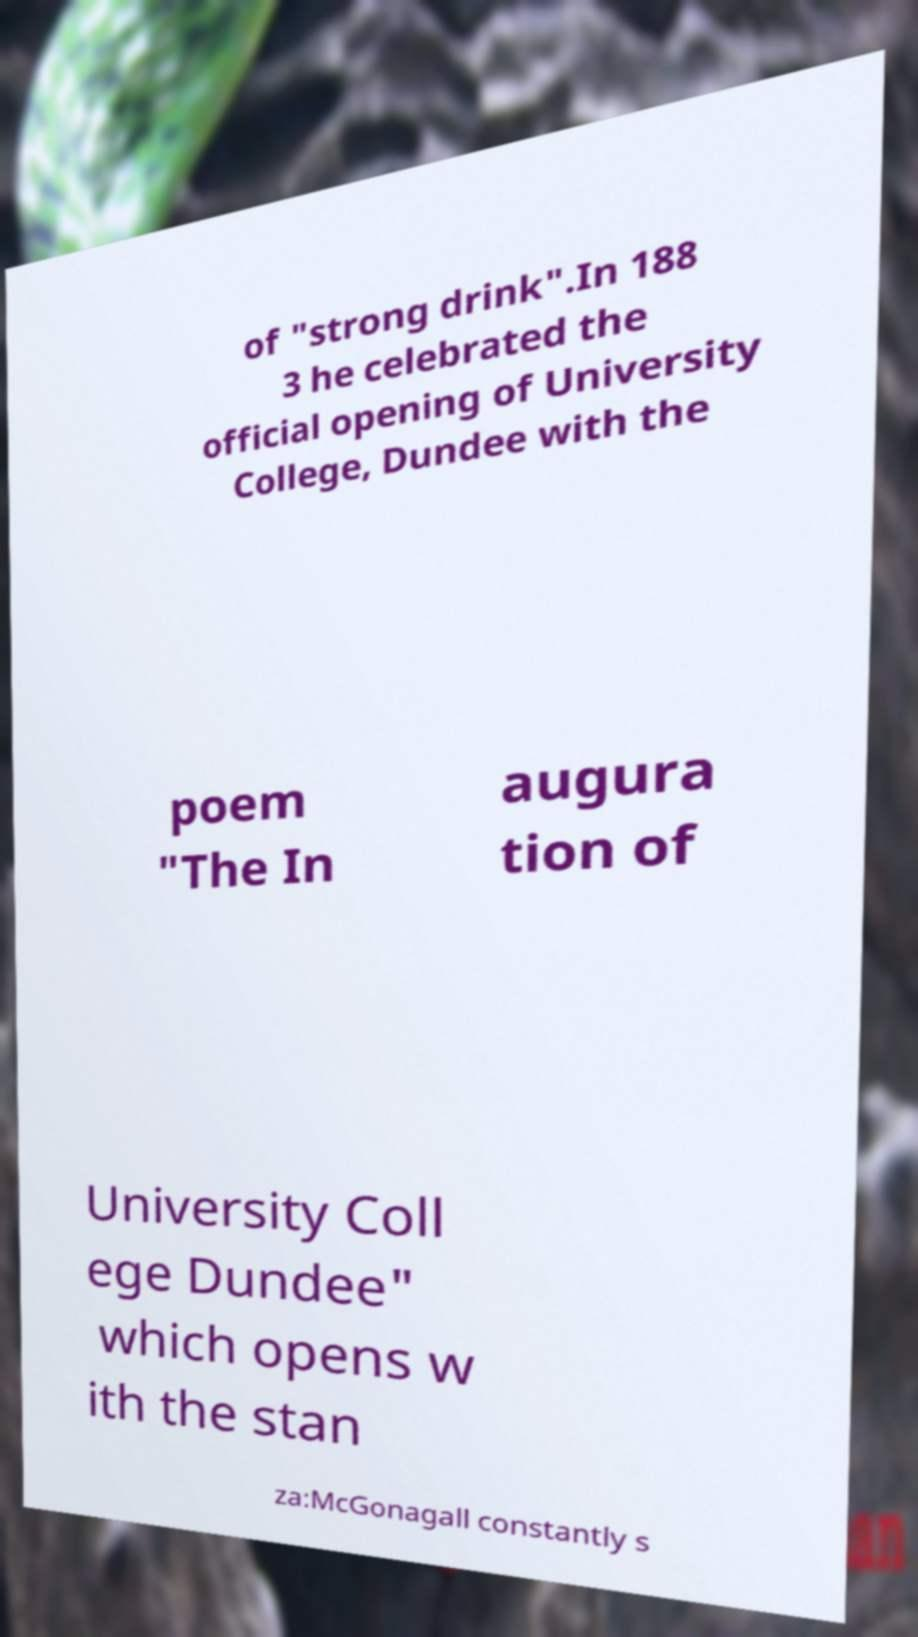Could you extract and type out the text from this image? of "strong drink".In 188 3 he celebrated the official opening of University College, Dundee with the poem "The In augura tion of University Coll ege Dundee" which opens w ith the stan za:McGonagall constantly s 